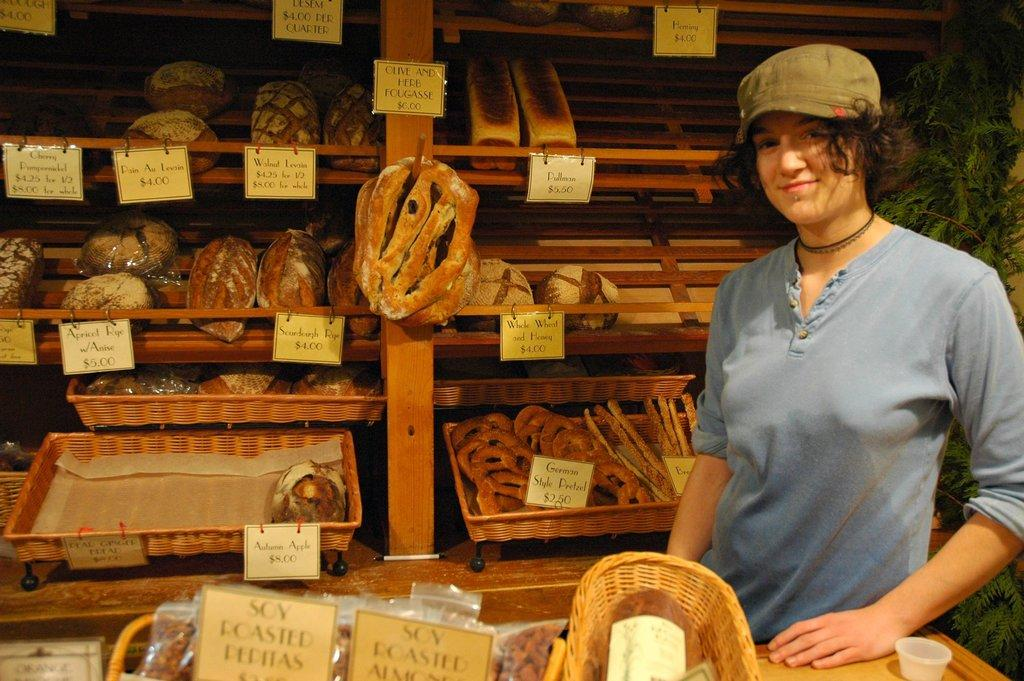<image>
Write a terse but informative summary of the picture. a woman standing with baskets of baked goods with one labeled 'soy roasted pepitas' 